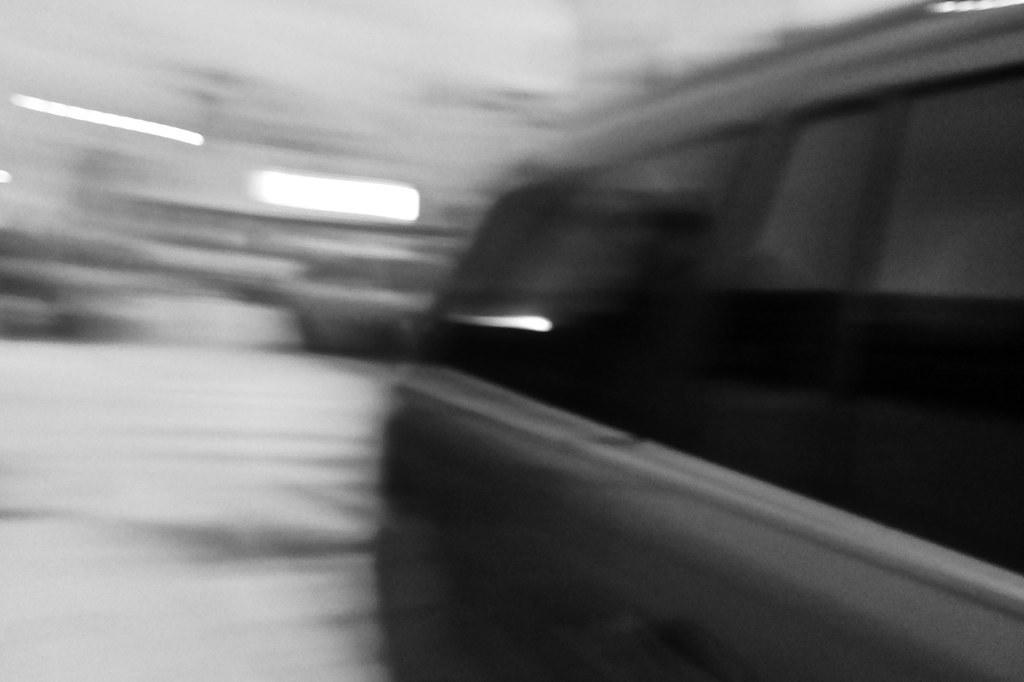What type of vehicle is in the image? There is a grey color car in the image. What is the car doing in the image? The car is moving. Can you describe the background of the image? The background of the image is blurred. How many mittens can be seen in the image? There are no mittens present in the image. What type of waste is visible in the image? There is no waste visible in the image. 